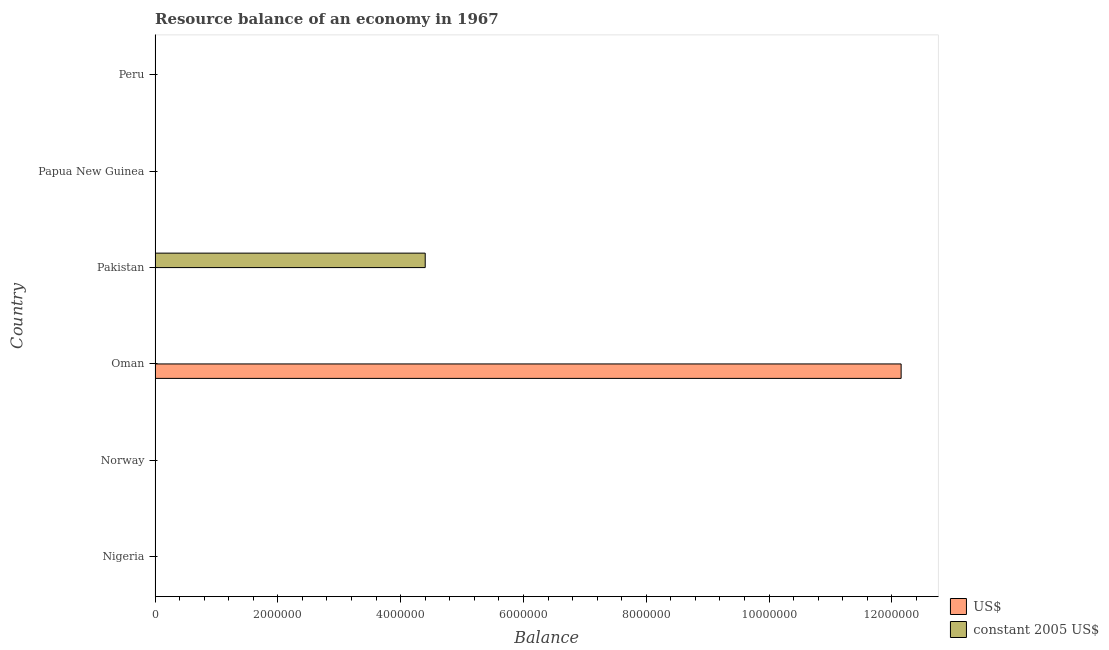How many different coloured bars are there?
Provide a succinct answer. 2. Are the number of bars per tick equal to the number of legend labels?
Your response must be concise. No. How many bars are there on the 4th tick from the top?
Ensure brevity in your answer.  1. In how many cases, is the number of bars for a given country not equal to the number of legend labels?
Make the answer very short. 6. Across all countries, what is the maximum resource balance in us$?
Your response must be concise. 1.22e+07. Across all countries, what is the minimum resource balance in constant us$?
Your answer should be very brief. 0. In which country was the resource balance in us$ maximum?
Keep it short and to the point. Oman. What is the total resource balance in us$ in the graph?
Your response must be concise. 1.22e+07. What is the average resource balance in constant us$ per country?
Provide a short and direct response. 7.33e+05. What is the difference between the highest and the lowest resource balance in constant us$?
Your answer should be compact. 4.40e+06. How many countries are there in the graph?
Offer a terse response. 6. What is the difference between two consecutive major ticks on the X-axis?
Your answer should be compact. 2.00e+06. Are the values on the major ticks of X-axis written in scientific E-notation?
Provide a short and direct response. No. Does the graph contain grids?
Your answer should be compact. No. What is the title of the graph?
Offer a terse response. Resource balance of an economy in 1967. What is the label or title of the X-axis?
Ensure brevity in your answer.  Balance. What is the label or title of the Y-axis?
Provide a succinct answer. Country. What is the Balance of US$ in Norway?
Ensure brevity in your answer.  0. What is the Balance of constant 2005 US$ in Norway?
Ensure brevity in your answer.  0. What is the Balance in US$ in Oman?
Offer a very short reply. 1.22e+07. What is the Balance of US$ in Pakistan?
Offer a very short reply. 0. What is the Balance of constant 2005 US$ in Pakistan?
Your answer should be compact. 4.40e+06. What is the Balance of US$ in Peru?
Your answer should be compact. 0. What is the Balance in constant 2005 US$ in Peru?
Offer a very short reply. 0. Across all countries, what is the maximum Balance in US$?
Provide a short and direct response. 1.22e+07. Across all countries, what is the maximum Balance of constant 2005 US$?
Your response must be concise. 4.40e+06. Across all countries, what is the minimum Balance in constant 2005 US$?
Keep it short and to the point. 0. What is the total Balance of US$ in the graph?
Your answer should be compact. 1.22e+07. What is the total Balance of constant 2005 US$ in the graph?
Provide a succinct answer. 4.40e+06. What is the difference between the Balance in US$ in Oman and the Balance in constant 2005 US$ in Pakistan?
Offer a terse response. 7.75e+06. What is the average Balance of US$ per country?
Provide a succinct answer. 2.03e+06. What is the average Balance of constant 2005 US$ per country?
Offer a terse response. 7.33e+05. What is the difference between the highest and the lowest Balance of US$?
Offer a very short reply. 1.22e+07. What is the difference between the highest and the lowest Balance of constant 2005 US$?
Give a very brief answer. 4.40e+06. 